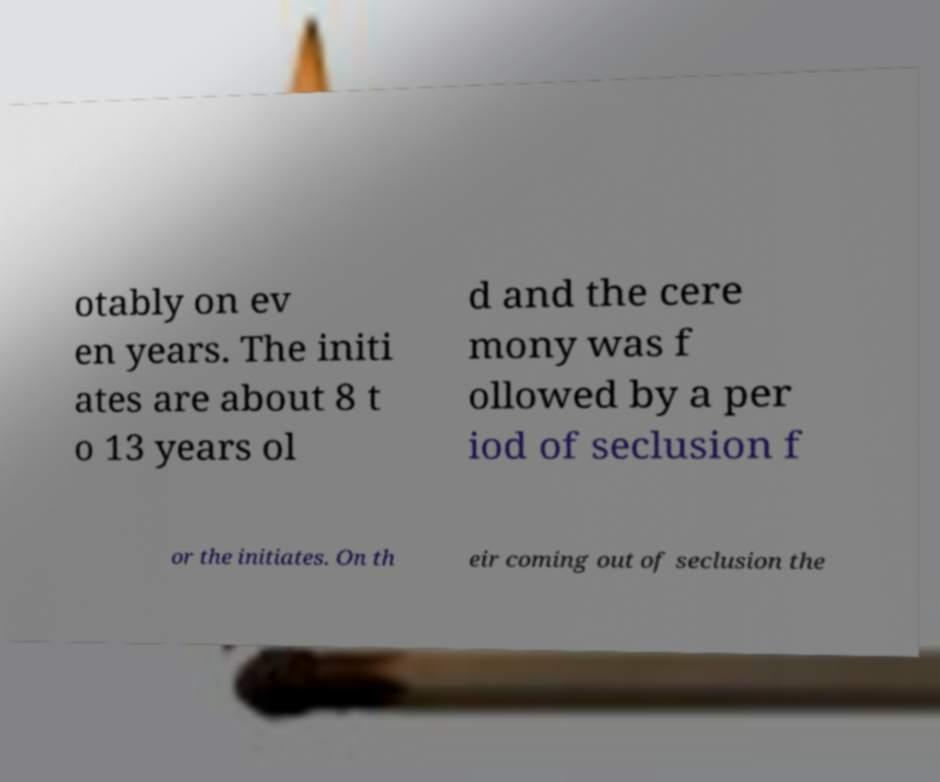Can you read and provide the text displayed in the image?This photo seems to have some interesting text. Can you extract and type it out for me? otably on ev en years. The initi ates are about 8 t o 13 years ol d and the cere mony was f ollowed by a per iod of seclusion f or the initiates. On th eir coming out of seclusion the 